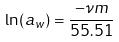Convert formula to latex. <formula><loc_0><loc_0><loc_500><loc_500>\ln ( a _ { w } ) = \frac { - \nu m } { 5 5 . 5 1 }</formula> 